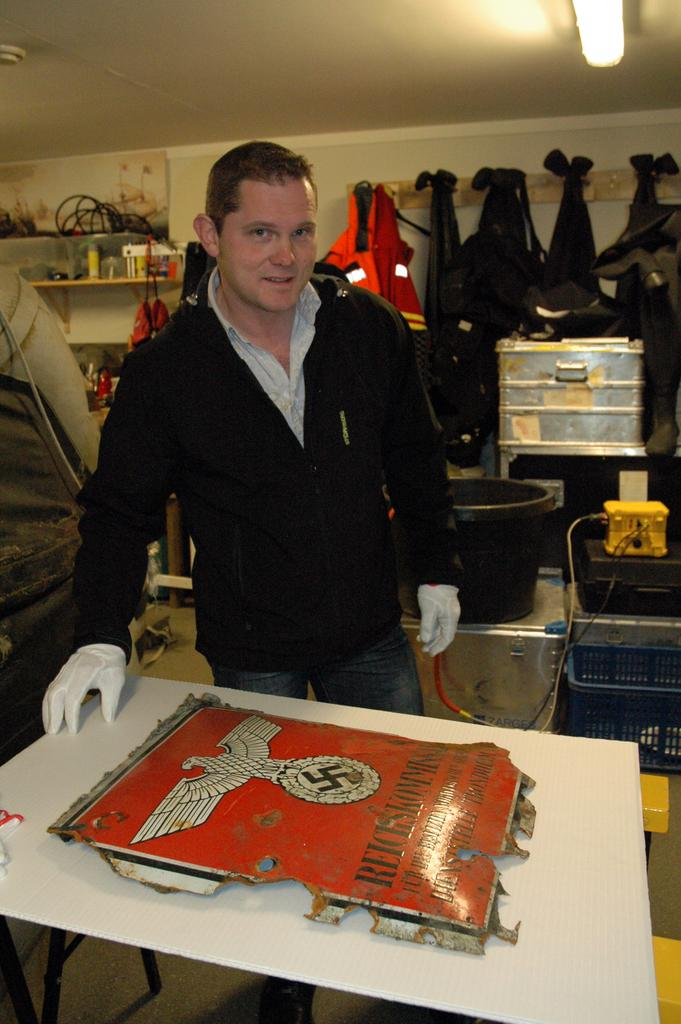Who or what is the main subject in the image? There is a person in the image. What is the person wearing? The person is wearing a sweater. What else can be seen behind the person? There are clothes visible behind the person. What is the source of light in the image? There is a light at the top of the image. What type of straw is growing on the ground in the image? There is no straw or ground visible in the image; it primarily features a person wearing a sweater and clothes in the background. 